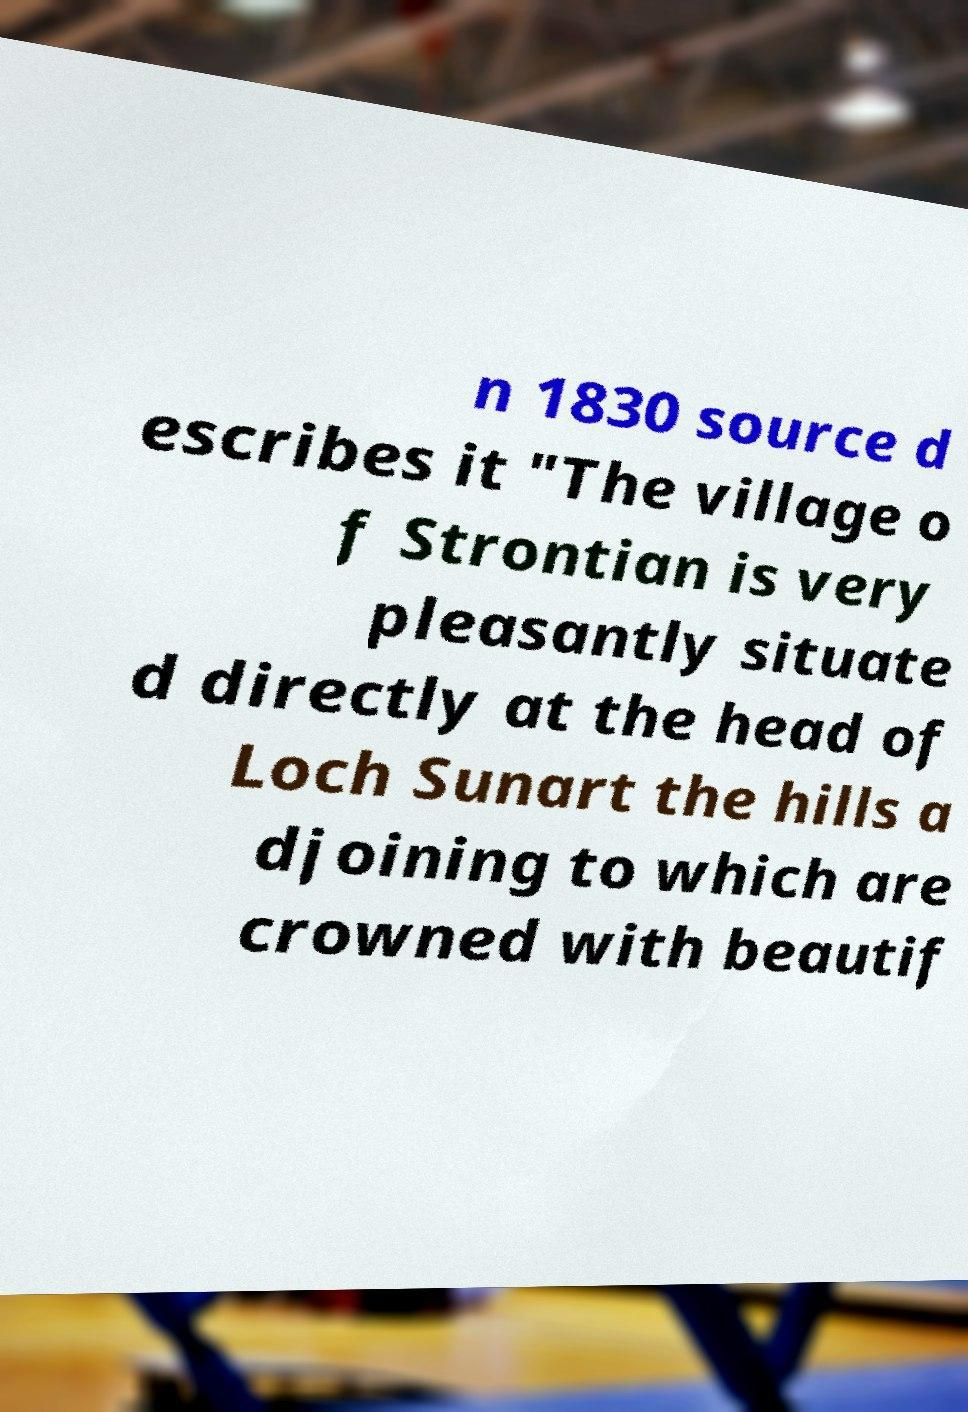Could you assist in decoding the text presented in this image and type it out clearly? n 1830 source d escribes it "The village o f Strontian is very pleasantly situate d directly at the head of Loch Sunart the hills a djoining to which are crowned with beautif 